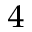<formula> <loc_0><loc_0><loc_500><loc_500>_ { 4 }</formula> 